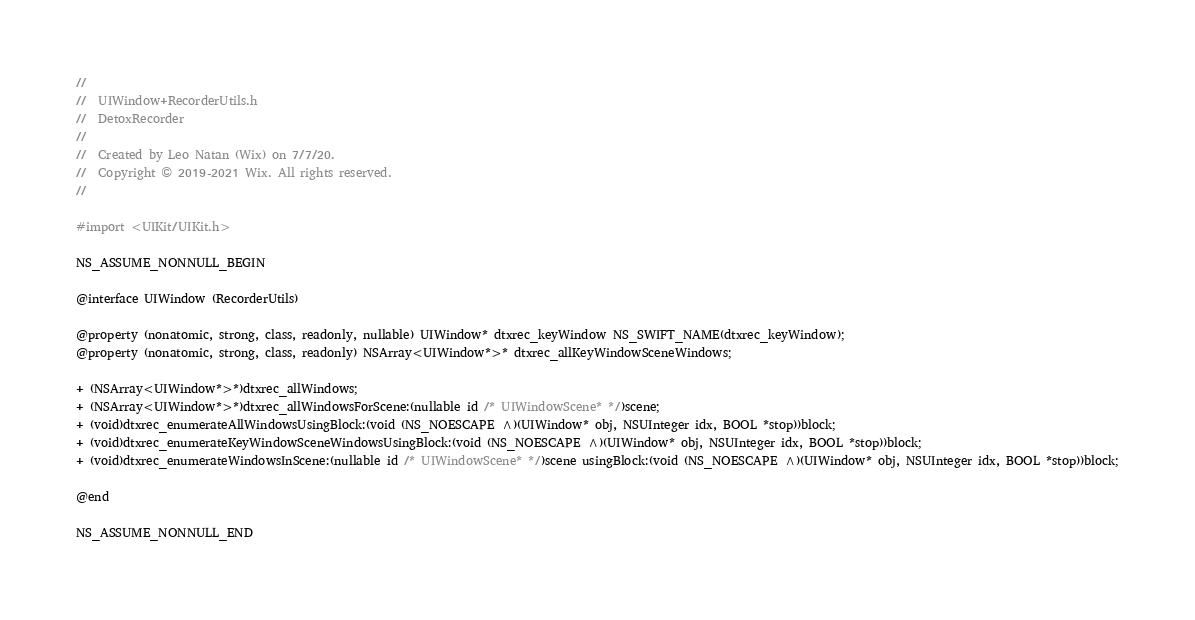Convert code to text. <code><loc_0><loc_0><loc_500><loc_500><_C_>//
//  UIWindow+RecorderUtils.h
//  DetoxRecorder
//
//  Created by Leo Natan (Wix) on 7/7/20.
//  Copyright © 2019-2021 Wix. All rights reserved.
//

#import <UIKit/UIKit.h>

NS_ASSUME_NONNULL_BEGIN

@interface UIWindow (RecorderUtils)

@property (nonatomic, strong, class, readonly, nullable) UIWindow* dtxrec_keyWindow NS_SWIFT_NAME(dtxrec_keyWindow);
@property (nonatomic, strong, class, readonly) NSArray<UIWindow*>* dtxrec_allKeyWindowSceneWindows;

+ (NSArray<UIWindow*>*)dtxrec_allWindows;
+ (NSArray<UIWindow*>*)dtxrec_allWindowsForScene:(nullable id /* UIWindowScene* */)scene;
+ (void)dtxrec_enumerateAllWindowsUsingBlock:(void (NS_NOESCAPE ^)(UIWindow* obj, NSUInteger idx, BOOL *stop))block;
+ (void)dtxrec_enumerateKeyWindowSceneWindowsUsingBlock:(void (NS_NOESCAPE ^)(UIWindow* obj, NSUInteger idx, BOOL *stop))block;
+ (void)dtxrec_enumerateWindowsInScene:(nullable id /* UIWindowScene* */)scene usingBlock:(void (NS_NOESCAPE ^)(UIWindow* obj, NSUInteger idx, BOOL *stop))block;

@end

NS_ASSUME_NONNULL_END
</code> 